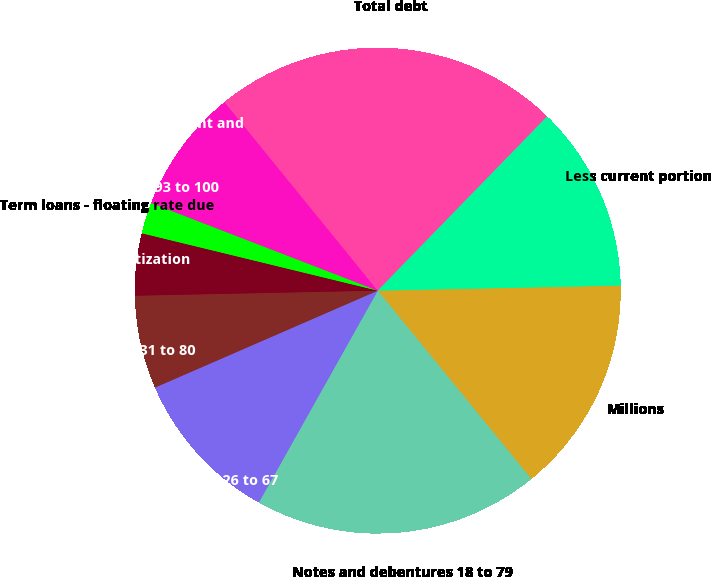<chart> <loc_0><loc_0><loc_500><loc_500><pie_chart><fcel>Millions<fcel>Notes and debentures 18 to 79<fcel>Equipment obligations 26 to 67<fcel>Capitalized leases 31 to 80<fcel>Receivables Securitization<fcel>Term loans - floating rate due<fcel>Medium-term notes 93 to 100<fcel>Unamortized discount and<fcel>Total debt<fcel>Less current portion<nl><fcel>14.45%<fcel>19.02%<fcel>10.33%<fcel>6.2%<fcel>4.13%<fcel>2.07%<fcel>0.01%<fcel>8.26%<fcel>23.14%<fcel>12.39%<nl></chart> 